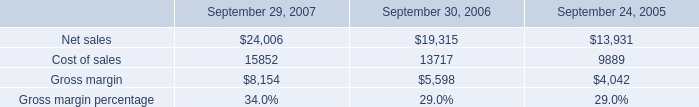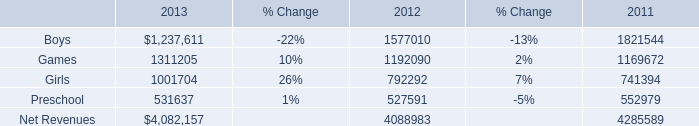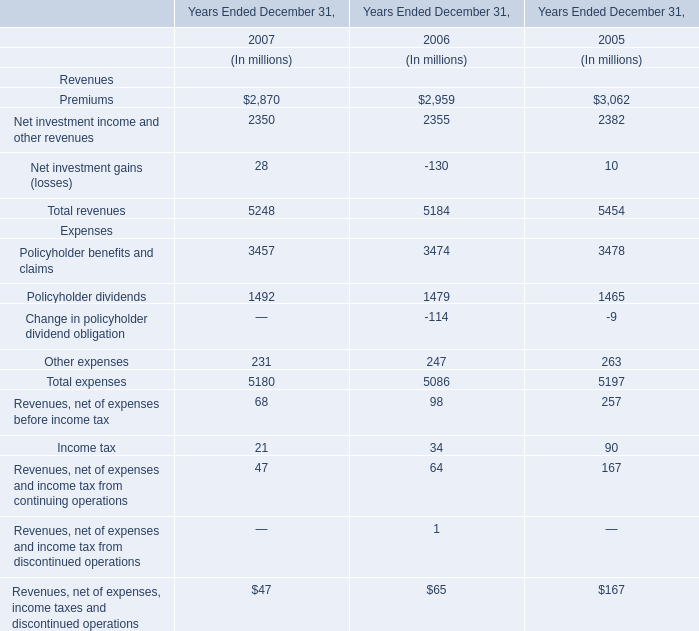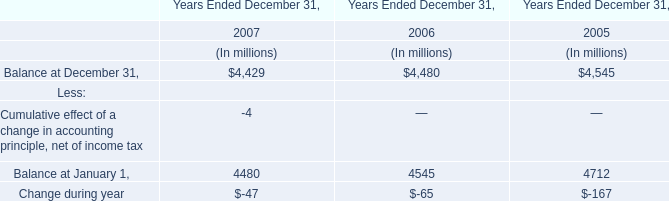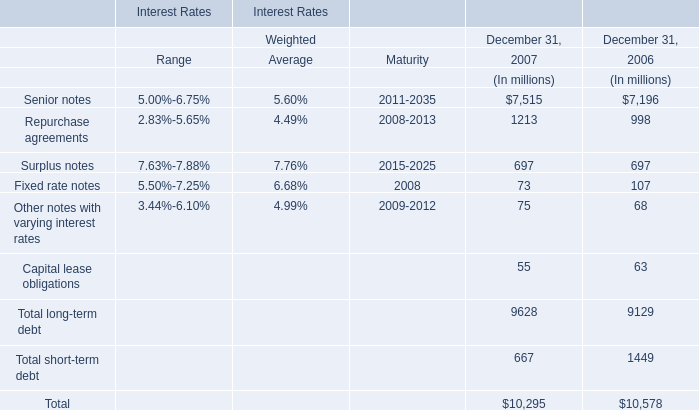What is the average amount of Net sales of September 29, 2007, and Senior notes of Interest Rates Maturity ? 
Computations: ((24006.0 + 20112035.0) / 2)
Answer: 10068020.5. 